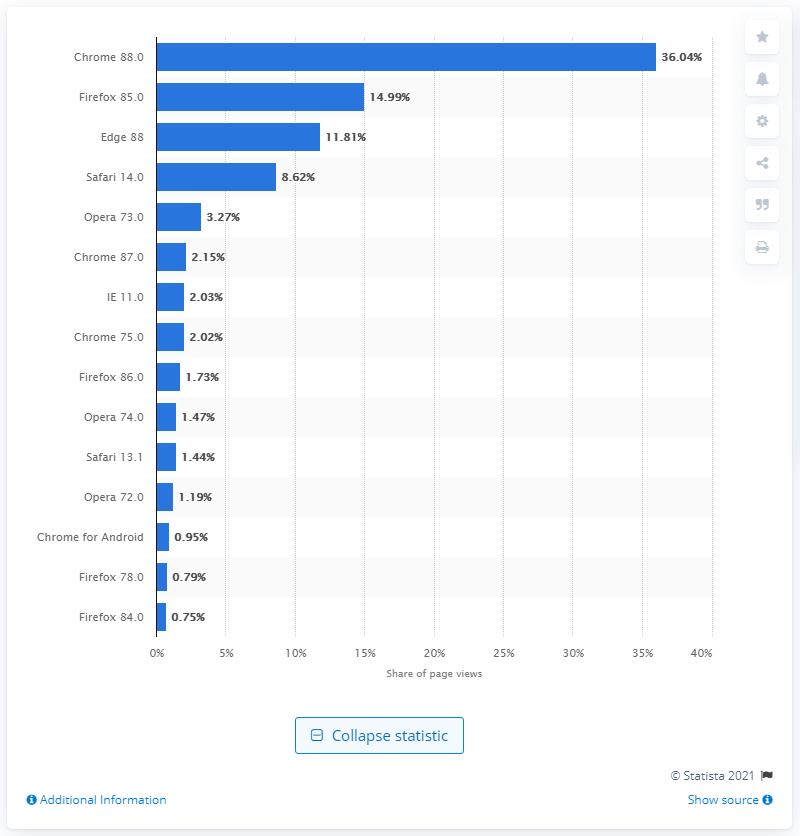Specify some key components in this picture. Firefox is the second most commonly used browser in Germany, with a usage percentage of 85.0%. According to recent data, Google Chrome is the most commonly used browser in Germany, with version 88.0 being among the most popular versions. 